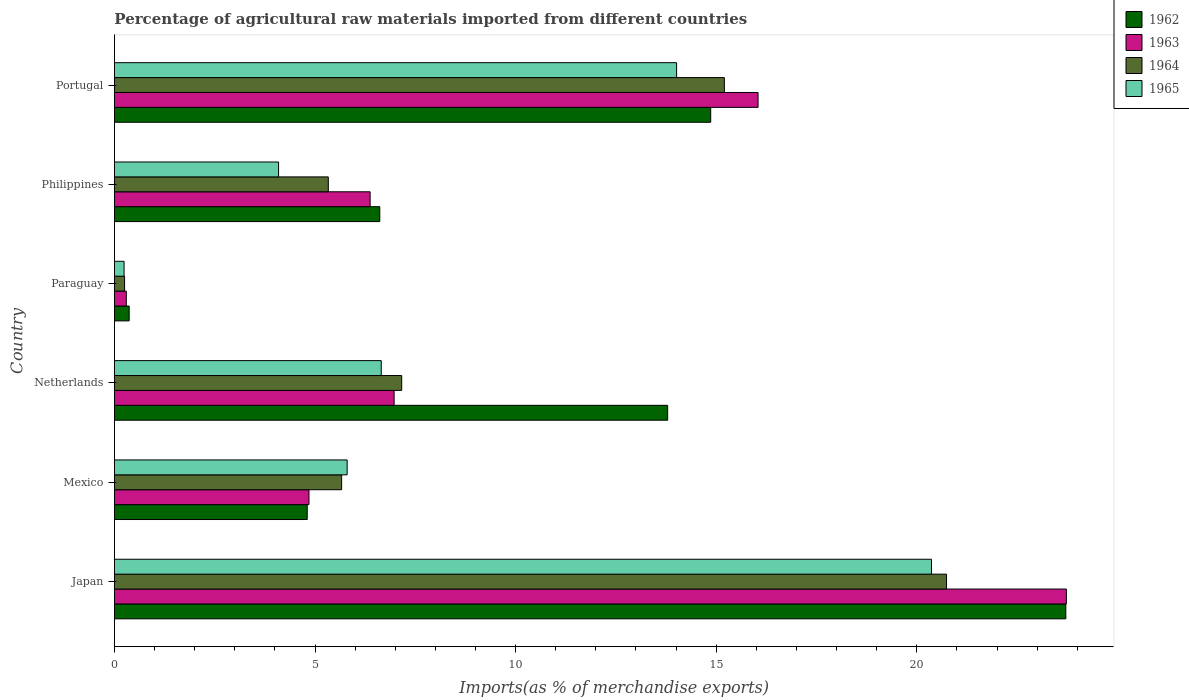How many different coloured bars are there?
Ensure brevity in your answer.  4. How many groups of bars are there?
Ensure brevity in your answer.  6. Are the number of bars on each tick of the Y-axis equal?
Make the answer very short. Yes. What is the label of the 6th group of bars from the top?
Give a very brief answer. Japan. What is the percentage of imports to different countries in 1962 in Portugal?
Ensure brevity in your answer.  14.86. Across all countries, what is the maximum percentage of imports to different countries in 1964?
Make the answer very short. 20.74. Across all countries, what is the minimum percentage of imports to different countries in 1965?
Ensure brevity in your answer.  0.24. In which country was the percentage of imports to different countries in 1964 maximum?
Offer a very short reply. Japan. In which country was the percentage of imports to different countries in 1965 minimum?
Give a very brief answer. Paraguay. What is the total percentage of imports to different countries in 1964 in the graph?
Keep it short and to the point. 54.35. What is the difference between the percentage of imports to different countries in 1965 in Mexico and that in Netherlands?
Ensure brevity in your answer.  -0.85. What is the difference between the percentage of imports to different countries in 1963 in Paraguay and the percentage of imports to different countries in 1964 in Netherlands?
Ensure brevity in your answer.  -6.86. What is the average percentage of imports to different countries in 1964 per country?
Your response must be concise. 9.06. What is the difference between the percentage of imports to different countries in 1963 and percentage of imports to different countries in 1964 in Paraguay?
Offer a very short reply. 0.04. What is the ratio of the percentage of imports to different countries in 1962 in Paraguay to that in Philippines?
Your answer should be compact. 0.06. Is the percentage of imports to different countries in 1963 in Japan less than that in Mexico?
Your response must be concise. No. Is the difference between the percentage of imports to different countries in 1963 in Netherlands and Philippines greater than the difference between the percentage of imports to different countries in 1964 in Netherlands and Philippines?
Provide a succinct answer. No. What is the difference between the highest and the second highest percentage of imports to different countries in 1962?
Offer a terse response. 8.85. What is the difference between the highest and the lowest percentage of imports to different countries in 1963?
Your answer should be very brief. 23.43. Is it the case that in every country, the sum of the percentage of imports to different countries in 1963 and percentage of imports to different countries in 1965 is greater than the sum of percentage of imports to different countries in 1962 and percentage of imports to different countries in 1964?
Your answer should be compact. No. What does the 2nd bar from the top in Portugal represents?
Your answer should be very brief. 1964. What does the 3rd bar from the bottom in Netherlands represents?
Offer a terse response. 1964. How many countries are there in the graph?
Ensure brevity in your answer.  6. What is the difference between two consecutive major ticks on the X-axis?
Make the answer very short. 5. Does the graph contain any zero values?
Keep it short and to the point. No. Where does the legend appear in the graph?
Offer a terse response. Top right. How many legend labels are there?
Provide a succinct answer. 4. What is the title of the graph?
Provide a succinct answer. Percentage of agricultural raw materials imported from different countries. Does "1976" appear as one of the legend labels in the graph?
Your answer should be very brief. No. What is the label or title of the X-axis?
Your answer should be very brief. Imports(as % of merchandise exports). What is the Imports(as % of merchandise exports) in 1962 in Japan?
Keep it short and to the point. 23.71. What is the Imports(as % of merchandise exports) of 1963 in Japan?
Ensure brevity in your answer.  23.73. What is the Imports(as % of merchandise exports) in 1964 in Japan?
Provide a succinct answer. 20.74. What is the Imports(as % of merchandise exports) of 1965 in Japan?
Offer a very short reply. 20.37. What is the Imports(as % of merchandise exports) in 1962 in Mexico?
Give a very brief answer. 4.81. What is the Imports(as % of merchandise exports) in 1963 in Mexico?
Make the answer very short. 4.85. What is the Imports(as % of merchandise exports) of 1964 in Mexico?
Provide a succinct answer. 5.66. What is the Imports(as % of merchandise exports) in 1965 in Mexico?
Ensure brevity in your answer.  5.8. What is the Imports(as % of merchandise exports) of 1962 in Netherlands?
Your response must be concise. 13.79. What is the Imports(as % of merchandise exports) of 1963 in Netherlands?
Make the answer very short. 6.97. What is the Imports(as % of merchandise exports) of 1964 in Netherlands?
Your response must be concise. 7.16. What is the Imports(as % of merchandise exports) of 1965 in Netherlands?
Give a very brief answer. 6.65. What is the Imports(as % of merchandise exports) of 1962 in Paraguay?
Make the answer very short. 0.37. What is the Imports(as % of merchandise exports) of 1963 in Paraguay?
Give a very brief answer. 0.3. What is the Imports(as % of merchandise exports) of 1964 in Paraguay?
Give a very brief answer. 0.25. What is the Imports(as % of merchandise exports) in 1965 in Paraguay?
Your answer should be very brief. 0.24. What is the Imports(as % of merchandise exports) of 1962 in Philippines?
Offer a very short reply. 6.61. What is the Imports(as % of merchandise exports) of 1963 in Philippines?
Your answer should be compact. 6.37. What is the Imports(as % of merchandise exports) in 1964 in Philippines?
Offer a very short reply. 5.33. What is the Imports(as % of merchandise exports) of 1965 in Philippines?
Offer a terse response. 4.09. What is the Imports(as % of merchandise exports) in 1962 in Portugal?
Offer a very short reply. 14.86. What is the Imports(as % of merchandise exports) of 1963 in Portugal?
Your answer should be very brief. 16.04. What is the Imports(as % of merchandise exports) of 1964 in Portugal?
Your response must be concise. 15.2. What is the Imports(as % of merchandise exports) of 1965 in Portugal?
Your response must be concise. 14.01. Across all countries, what is the maximum Imports(as % of merchandise exports) of 1962?
Offer a very short reply. 23.71. Across all countries, what is the maximum Imports(as % of merchandise exports) in 1963?
Offer a very short reply. 23.73. Across all countries, what is the maximum Imports(as % of merchandise exports) of 1964?
Keep it short and to the point. 20.74. Across all countries, what is the maximum Imports(as % of merchandise exports) of 1965?
Your answer should be compact. 20.37. Across all countries, what is the minimum Imports(as % of merchandise exports) of 1962?
Give a very brief answer. 0.37. Across all countries, what is the minimum Imports(as % of merchandise exports) in 1963?
Ensure brevity in your answer.  0.3. Across all countries, what is the minimum Imports(as % of merchandise exports) in 1964?
Offer a terse response. 0.25. Across all countries, what is the minimum Imports(as % of merchandise exports) in 1965?
Offer a very short reply. 0.24. What is the total Imports(as % of merchandise exports) in 1962 in the graph?
Offer a terse response. 64.16. What is the total Imports(as % of merchandise exports) in 1963 in the graph?
Give a very brief answer. 58.26. What is the total Imports(as % of merchandise exports) in 1964 in the graph?
Offer a very short reply. 54.35. What is the total Imports(as % of merchandise exports) in 1965 in the graph?
Give a very brief answer. 51.16. What is the difference between the Imports(as % of merchandise exports) in 1962 in Japan and that in Mexico?
Your answer should be very brief. 18.91. What is the difference between the Imports(as % of merchandise exports) in 1963 in Japan and that in Mexico?
Your answer should be very brief. 18.88. What is the difference between the Imports(as % of merchandise exports) of 1964 in Japan and that in Mexico?
Your answer should be compact. 15.08. What is the difference between the Imports(as % of merchandise exports) of 1965 in Japan and that in Mexico?
Make the answer very short. 14.56. What is the difference between the Imports(as % of merchandise exports) in 1962 in Japan and that in Netherlands?
Provide a succinct answer. 9.93. What is the difference between the Imports(as % of merchandise exports) in 1963 in Japan and that in Netherlands?
Keep it short and to the point. 16.76. What is the difference between the Imports(as % of merchandise exports) in 1964 in Japan and that in Netherlands?
Give a very brief answer. 13.58. What is the difference between the Imports(as % of merchandise exports) of 1965 in Japan and that in Netherlands?
Offer a very short reply. 13.72. What is the difference between the Imports(as % of merchandise exports) in 1962 in Japan and that in Paraguay?
Your answer should be compact. 23.35. What is the difference between the Imports(as % of merchandise exports) of 1963 in Japan and that in Paraguay?
Provide a succinct answer. 23.43. What is the difference between the Imports(as % of merchandise exports) in 1964 in Japan and that in Paraguay?
Provide a short and direct response. 20.49. What is the difference between the Imports(as % of merchandise exports) in 1965 in Japan and that in Paraguay?
Offer a terse response. 20.13. What is the difference between the Imports(as % of merchandise exports) in 1962 in Japan and that in Philippines?
Make the answer very short. 17.1. What is the difference between the Imports(as % of merchandise exports) in 1963 in Japan and that in Philippines?
Offer a very short reply. 17.36. What is the difference between the Imports(as % of merchandise exports) of 1964 in Japan and that in Philippines?
Give a very brief answer. 15.41. What is the difference between the Imports(as % of merchandise exports) in 1965 in Japan and that in Philippines?
Make the answer very short. 16.27. What is the difference between the Imports(as % of merchandise exports) of 1962 in Japan and that in Portugal?
Make the answer very short. 8.85. What is the difference between the Imports(as % of merchandise exports) of 1963 in Japan and that in Portugal?
Your response must be concise. 7.69. What is the difference between the Imports(as % of merchandise exports) in 1964 in Japan and that in Portugal?
Offer a terse response. 5.54. What is the difference between the Imports(as % of merchandise exports) in 1965 in Japan and that in Portugal?
Make the answer very short. 6.35. What is the difference between the Imports(as % of merchandise exports) in 1962 in Mexico and that in Netherlands?
Your answer should be very brief. -8.98. What is the difference between the Imports(as % of merchandise exports) of 1963 in Mexico and that in Netherlands?
Your answer should be compact. -2.12. What is the difference between the Imports(as % of merchandise exports) in 1964 in Mexico and that in Netherlands?
Your response must be concise. -1.5. What is the difference between the Imports(as % of merchandise exports) in 1965 in Mexico and that in Netherlands?
Your response must be concise. -0.85. What is the difference between the Imports(as % of merchandise exports) in 1962 in Mexico and that in Paraguay?
Offer a terse response. 4.44. What is the difference between the Imports(as % of merchandise exports) in 1963 in Mexico and that in Paraguay?
Keep it short and to the point. 4.55. What is the difference between the Imports(as % of merchandise exports) in 1964 in Mexico and that in Paraguay?
Offer a very short reply. 5.41. What is the difference between the Imports(as % of merchandise exports) in 1965 in Mexico and that in Paraguay?
Offer a terse response. 5.56. What is the difference between the Imports(as % of merchandise exports) in 1962 in Mexico and that in Philippines?
Provide a short and direct response. -1.81. What is the difference between the Imports(as % of merchandise exports) of 1963 in Mexico and that in Philippines?
Your answer should be compact. -1.52. What is the difference between the Imports(as % of merchandise exports) in 1964 in Mexico and that in Philippines?
Ensure brevity in your answer.  0.33. What is the difference between the Imports(as % of merchandise exports) of 1965 in Mexico and that in Philippines?
Offer a very short reply. 1.71. What is the difference between the Imports(as % of merchandise exports) in 1962 in Mexico and that in Portugal?
Provide a succinct answer. -10.06. What is the difference between the Imports(as % of merchandise exports) in 1963 in Mexico and that in Portugal?
Offer a very short reply. -11.19. What is the difference between the Imports(as % of merchandise exports) in 1964 in Mexico and that in Portugal?
Provide a short and direct response. -9.54. What is the difference between the Imports(as % of merchandise exports) in 1965 in Mexico and that in Portugal?
Make the answer very short. -8.21. What is the difference between the Imports(as % of merchandise exports) in 1962 in Netherlands and that in Paraguay?
Ensure brevity in your answer.  13.42. What is the difference between the Imports(as % of merchandise exports) in 1963 in Netherlands and that in Paraguay?
Make the answer very short. 6.68. What is the difference between the Imports(as % of merchandise exports) in 1964 in Netherlands and that in Paraguay?
Make the answer very short. 6.91. What is the difference between the Imports(as % of merchandise exports) of 1965 in Netherlands and that in Paraguay?
Provide a succinct answer. 6.41. What is the difference between the Imports(as % of merchandise exports) of 1962 in Netherlands and that in Philippines?
Offer a terse response. 7.18. What is the difference between the Imports(as % of merchandise exports) in 1963 in Netherlands and that in Philippines?
Your answer should be very brief. 0.6. What is the difference between the Imports(as % of merchandise exports) in 1964 in Netherlands and that in Philippines?
Your response must be concise. 1.83. What is the difference between the Imports(as % of merchandise exports) in 1965 in Netherlands and that in Philippines?
Offer a terse response. 2.56. What is the difference between the Imports(as % of merchandise exports) of 1962 in Netherlands and that in Portugal?
Your answer should be compact. -1.07. What is the difference between the Imports(as % of merchandise exports) of 1963 in Netherlands and that in Portugal?
Your response must be concise. -9.07. What is the difference between the Imports(as % of merchandise exports) of 1964 in Netherlands and that in Portugal?
Provide a short and direct response. -8.04. What is the difference between the Imports(as % of merchandise exports) in 1965 in Netherlands and that in Portugal?
Give a very brief answer. -7.36. What is the difference between the Imports(as % of merchandise exports) of 1962 in Paraguay and that in Philippines?
Keep it short and to the point. -6.25. What is the difference between the Imports(as % of merchandise exports) in 1963 in Paraguay and that in Philippines?
Your answer should be compact. -6.08. What is the difference between the Imports(as % of merchandise exports) of 1964 in Paraguay and that in Philippines?
Make the answer very short. -5.08. What is the difference between the Imports(as % of merchandise exports) in 1965 in Paraguay and that in Philippines?
Your answer should be compact. -3.85. What is the difference between the Imports(as % of merchandise exports) of 1962 in Paraguay and that in Portugal?
Give a very brief answer. -14.5. What is the difference between the Imports(as % of merchandise exports) of 1963 in Paraguay and that in Portugal?
Your response must be concise. -15.75. What is the difference between the Imports(as % of merchandise exports) in 1964 in Paraguay and that in Portugal?
Give a very brief answer. -14.95. What is the difference between the Imports(as % of merchandise exports) of 1965 in Paraguay and that in Portugal?
Ensure brevity in your answer.  -13.77. What is the difference between the Imports(as % of merchandise exports) of 1962 in Philippines and that in Portugal?
Keep it short and to the point. -8.25. What is the difference between the Imports(as % of merchandise exports) in 1963 in Philippines and that in Portugal?
Offer a terse response. -9.67. What is the difference between the Imports(as % of merchandise exports) in 1964 in Philippines and that in Portugal?
Provide a succinct answer. -9.87. What is the difference between the Imports(as % of merchandise exports) of 1965 in Philippines and that in Portugal?
Give a very brief answer. -9.92. What is the difference between the Imports(as % of merchandise exports) in 1962 in Japan and the Imports(as % of merchandise exports) in 1963 in Mexico?
Your answer should be compact. 18.87. What is the difference between the Imports(as % of merchandise exports) of 1962 in Japan and the Imports(as % of merchandise exports) of 1964 in Mexico?
Provide a short and direct response. 18.05. What is the difference between the Imports(as % of merchandise exports) in 1962 in Japan and the Imports(as % of merchandise exports) in 1965 in Mexico?
Your response must be concise. 17.91. What is the difference between the Imports(as % of merchandise exports) in 1963 in Japan and the Imports(as % of merchandise exports) in 1964 in Mexico?
Give a very brief answer. 18.07. What is the difference between the Imports(as % of merchandise exports) in 1963 in Japan and the Imports(as % of merchandise exports) in 1965 in Mexico?
Your answer should be compact. 17.93. What is the difference between the Imports(as % of merchandise exports) of 1964 in Japan and the Imports(as % of merchandise exports) of 1965 in Mexico?
Ensure brevity in your answer.  14.94. What is the difference between the Imports(as % of merchandise exports) of 1962 in Japan and the Imports(as % of merchandise exports) of 1963 in Netherlands?
Offer a very short reply. 16.74. What is the difference between the Imports(as % of merchandise exports) of 1962 in Japan and the Imports(as % of merchandise exports) of 1964 in Netherlands?
Ensure brevity in your answer.  16.55. What is the difference between the Imports(as % of merchandise exports) of 1962 in Japan and the Imports(as % of merchandise exports) of 1965 in Netherlands?
Your answer should be very brief. 17.06. What is the difference between the Imports(as % of merchandise exports) of 1963 in Japan and the Imports(as % of merchandise exports) of 1964 in Netherlands?
Make the answer very short. 16.57. What is the difference between the Imports(as % of merchandise exports) in 1963 in Japan and the Imports(as % of merchandise exports) in 1965 in Netherlands?
Make the answer very short. 17.08. What is the difference between the Imports(as % of merchandise exports) of 1964 in Japan and the Imports(as % of merchandise exports) of 1965 in Netherlands?
Provide a succinct answer. 14.09. What is the difference between the Imports(as % of merchandise exports) of 1962 in Japan and the Imports(as % of merchandise exports) of 1963 in Paraguay?
Provide a short and direct response. 23.42. What is the difference between the Imports(as % of merchandise exports) of 1962 in Japan and the Imports(as % of merchandise exports) of 1964 in Paraguay?
Your answer should be very brief. 23.46. What is the difference between the Imports(as % of merchandise exports) in 1962 in Japan and the Imports(as % of merchandise exports) in 1965 in Paraguay?
Your answer should be very brief. 23.47. What is the difference between the Imports(as % of merchandise exports) in 1963 in Japan and the Imports(as % of merchandise exports) in 1964 in Paraguay?
Your answer should be compact. 23.48. What is the difference between the Imports(as % of merchandise exports) in 1963 in Japan and the Imports(as % of merchandise exports) in 1965 in Paraguay?
Provide a short and direct response. 23.49. What is the difference between the Imports(as % of merchandise exports) of 1964 in Japan and the Imports(as % of merchandise exports) of 1965 in Paraguay?
Provide a short and direct response. 20.5. What is the difference between the Imports(as % of merchandise exports) of 1962 in Japan and the Imports(as % of merchandise exports) of 1963 in Philippines?
Provide a succinct answer. 17.34. What is the difference between the Imports(as % of merchandise exports) in 1962 in Japan and the Imports(as % of merchandise exports) in 1964 in Philippines?
Make the answer very short. 18.38. What is the difference between the Imports(as % of merchandise exports) in 1962 in Japan and the Imports(as % of merchandise exports) in 1965 in Philippines?
Provide a succinct answer. 19.62. What is the difference between the Imports(as % of merchandise exports) in 1963 in Japan and the Imports(as % of merchandise exports) in 1964 in Philippines?
Your answer should be compact. 18.4. What is the difference between the Imports(as % of merchandise exports) of 1963 in Japan and the Imports(as % of merchandise exports) of 1965 in Philippines?
Your response must be concise. 19.64. What is the difference between the Imports(as % of merchandise exports) of 1964 in Japan and the Imports(as % of merchandise exports) of 1965 in Philippines?
Ensure brevity in your answer.  16.65. What is the difference between the Imports(as % of merchandise exports) of 1962 in Japan and the Imports(as % of merchandise exports) of 1963 in Portugal?
Your answer should be compact. 7.67. What is the difference between the Imports(as % of merchandise exports) of 1962 in Japan and the Imports(as % of merchandise exports) of 1964 in Portugal?
Offer a very short reply. 8.51. What is the difference between the Imports(as % of merchandise exports) of 1962 in Japan and the Imports(as % of merchandise exports) of 1965 in Portugal?
Offer a very short reply. 9.7. What is the difference between the Imports(as % of merchandise exports) in 1963 in Japan and the Imports(as % of merchandise exports) in 1964 in Portugal?
Give a very brief answer. 8.53. What is the difference between the Imports(as % of merchandise exports) in 1963 in Japan and the Imports(as % of merchandise exports) in 1965 in Portugal?
Offer a terse response. 9.72. What is the difference between the Imports(as % of merchandise exports) of 1964 in Japan and the Imports(as % of merchandise exports) of 1965 in Portugal?
Make the answer very short. 6.73. What is the difference between the Imports(as % of merchandise exports) of 1962 in Mexico and the Imports(as % of merchandise exports) of 1963 in Netherlands?
Your response must be concise. -2.17. What is the difference between the Imports(as % of merchandise exports) of 1962 in Mexico and the Imports(as % of merchandise exports) of 1964 in Netherlands?
Give a very brief answer. -2.36. What is the difference between the Imports(as % of merchandise exports) of 1962 in Mexico and the Imports(as % of merchandise exports) of 1965 in Netherlands?
Make the answer very short. -1.85. What is the difference between the Imports(as % of merchandise exports) of 1963 in Mexico and the Imports(as % of merchandise exports) of 1964 in Netherlands?
Offer a very short reply. -2.31. What is the difference between the Imports(as % of merchandise exports) in 1963 in Mexico and the Imports(as % of merchandise exports) in 1965 in Netherlands?
Your answer should be very brief. -1.8. What is the difference between the Imports(as % of merchandise exports) of 1964 in Mexico and the Imports(as % of merchandise exports) of 1965 in Netherlands?
Give a very brief answer. -0.99. What is the difference between the Imports(as % of merchandise exports) in 1962 in Mexico and the Imports(as % of merchandise exports) in 1963 in Paraguay?
Give a very brief answer. 4.51. What is the difference between the Imports(as % of merchandise exports) in 1962 in Mexico and the Imports(as % of merchandise exports) in 1964 in Paraguay?
Give a very brief answer. 4.55. What is the difference between the Imports(as % of merchandise exports) in 1962 in Mexico and the Imports(as % of merchandise exports) in 1965 in Paraguay?
Your answer should be compact. 4.57. What is the difference between the Imports(as % of merchandise exports) in 1963 in Mexico and the Imports(as % of merchandise exports) in 1964 in Paraguay?
Offer a terse response. 4.6. What is the difference between the Imports(as % of merchandise exports) of 1963 in Mexico and the Imports(as % of merchandise exports) of 1965 in Paraguay?
Your answer should be very brief. 4.61. What is the difference between the Imports(as % of merchandise exports) of 1964 in Mexico and the Imports(as % of merchandise exports) of 1965 in Paraguay?
Provide a succinct answer. 5.42. What is the difference between the Imports(as % of merchandise exports) of 1962 in Mexico and the Imports(as % of merchandise exports) of 1963 in Philippines?
Your response must be concise. -1.57. What is the difference between the Imports(as % of merchandise exports) of 1962 in Mexico and the Imports(as % of merchandise exports) of 1964 in Philippines?
Your answer should be compact. -0.53. What is the difference between the Imports(as % of merchandise exports) in 1962 in Mexico and the Imports(as % of merchandise exports) in 1965 in Philippines?
Your answer should be compact. 0.71. What is the difference between the Imports(as % of merchandise exports) of 1963 in Mexico and the Imports(as % of merchandise exports) of 1964 in Philippines?
Make the answer very short. -0.48. What is the difference between the Imports(as % of merchandise exports) of 1963 in Mexico and the Imports(as % of merchandise exports) of 1965 in Philippines?
Your answer should be very brief. 0.76. What is the difference between the Imports(as % of merchandise exports) of 1964 in Mexico and the Imports(as % of merchandise exports) of 1965 in Philippines?
Ensure brevity in your answer.  1.57. What is the difference between the Imports(as % of merchandise exports) of 1962 in Mexico and the Imports(as % of merchandise exports) of 1963 in Portugal?
Your answer should be very brief. -11.24. What is the difference between the Imports(as % of merchandise exports) in 1962 in Mexico and the Imports(as % of merchandise exports) in 1964 in Portugal?
Offer a very short reply. -10.4. What is the difference between the Imports(as % of merchandise exports) in 1962 in Mexico and the Imports(as % of merchandise exports) in 1965 in Portugal?
Offer a very short reply. -9.21. What is the difference between the Imports(as % of merchandise exports) in 1963 in Mexico and the Imports(as % of merchandise exports) in 1964 in Portugal?
Give a very brief answer. -10.35. What is the difference between the Imports(as % of merchandise exports) in 1963 in Mexico and the Imports(as % of merchandise exports) in 1965 in Portugal?
Offer a terse response. -9.16. What is the difference between the Imports(as % of merchandise exports) in 1964 in Mexico and the Imports(as % of merchandise exports) in 1965 in Portugal?
Offer a terse response. -8.35. What is the difference between the Imports(as % of merchandise exports) in 1962 in Netherlands and the Imports(as % of merchandise exports) in 1963 in Paraguay?
Your answer should be very brief. 13.49. What is the difference between the Imports(as % of merchandise exports) of 1962 in Netherlands and the Imports(as % of merchandise exports) of 1964 in Paraguay?
Offer a terse response. 13.54. What is the difference between the Imports(as % of merchandise exports) of 1962 in Netherlands and the Imports(as % of merchandise exports) of 1965 in Paraguay?
Ensure brevity in your answer.  13.55. What is the difference between the Imports(as % of merchandise exports) of 1963 in Netherlands and the Imports(as % of merchandise exports) of 1964 in Paraguay?
Offer a very short reply. 6.72. What is the difference between the Imports(as % of merchandise exports) of 1963 in Netherlands and the Imports(as % of merchandise exports) of 1965 in Paraguay?
Your answer should be very brief. 6.73. What is the difference between the Imports(as % of merchandise exports) of 1964 in Netherlands and the Imports(as % of merchandise exports) of 1965 in Paraguay?
Ensure brevity in your answer.  6.92. What is the difference between the Imports(as % of merchandise exports) of 1962 in Netherlands and the Imports(as % of merchandise exports) of 1963 in Philippines?
Offer a terse response. 7.42. What is the difference between the Imports(as % of merchandise exports) in 1962 in Netherlands and the Imports(as % of merchandise exports) in 1964 in Philippines?
Give a very brief answer. 8.46. What is the difference between the Imports(as % of merchandise exports) of 1962 in Netherlands and the Imports(as % of merchandise exports) of 1965 in Philippines?
Keep it short and to the point. 9.7. What is the difference between the Imports(as % of merchandise exports) in 1963 in Netherlands and the Imports(as % of merchandise exports) in 1964 in Philippines?
Your response must be concise. 1.64. What is the difference between the Imports(as % of merchandise exports) in 1963 in Netherlands and the Imports(as % of merchandise exports) in 1965 in Philippines?
Offer a terse response. 2.88. What is the difference between the Imports(as % of merchandise exports) in 1964 in Netherlands and the Imports(as % of merchandise exports) in 1965 in Philippines?
Your response must be concise. 3.07. What is the difference between the Imports(as % of merchandise exports) of 1962 in Netherlands and the Imports(as % of merchandise exports) of 1963 in Portugal?
Give a very brief answer. -2.25. What is the difference between the Imports(as % of merchandise exports) of 1962 in Netherlands and the Imports(as % of merchandise exports) of 1964 in Portugal?
Your response must be concise. -1.41. What is the difference between the Imports(as % of merchandise exports) of 1962 in Netherlands and the Imports(as % of merchandise exports) of 1965 in Portugal?
Offer a terse response. -0.22. What is the difference between the Imports(as % of merchandise exports) of 1963 in Netherlands and the Imports(as % of merchandise exports) of 1964 in Portugal?
Offer a terse response. -8.23. What is the difference between the Imports(as % of merchandise exports) in 1963 in Netherlands and the Imports(as % of merchandise exports) in 1965 in Portugal?
Provide a succinct answer. -7.04. What is the difference between the Imports(as % of merchandise exports) of 1964 in Netherlands and the Imports(as % of merchandise exports) of 1965 in Portugal?
Make the answer very short. -6.85. What is the difference between the Imports(as % of merchandise exports) of 1962 in Paraguay and the Imports(as % of merchandise exports) of 1963 in Philippines?
Ensure brevity in your answer.  -6.01. What is the difference between the Imports(as % of merchandise exports) in 1962 in Paraguay and the Imports(as % of merchandise exports) in 1964 in Philippines?
Provide a short and direct response. -4.96. What is the difference between the Imports(as % of merchandise exports) of 1962 in Paraguay and the Imports(as % of merchandise exports) of 1965 in Philippines?
Provide a succinct answer. -3.72. What is the difference between the Imports(as % of merchandise exports) in 1963 in Paraguay and the Imports(as % of merchandise exports) in 1964 in Philippines?
Offer a terse response. -5.04. What is the difference between the Imports(as % of merchandise exports) in 1963 in Paraguay and the Imports(as % of merchandise exports) in 1965 in Philippines?
Offer a terse response. -3.8. What is the difference between the Imports(as % of merchandise exports) of 1964 in Paraguay and the Imports(as % of merchandise exports) of 1965 in Philippines?
Your answer should be very brief. -3.84. What is the difference between the Imports(as % of merchandise exports) of 1962 in Paraguay and the Imports(as % of merchandise exports) of 1963 in Portugal?
Provide a succinct answer. -15.68. What is the difference between the Imports(as % of merchandise exports) in 1962 in Paraguay and the Imports(as % of merchandise exports) in 1964 in Portugal?
Your answer should be very brief. -14.84. What is the difference between the Imports(as % of merchandise exports) of 1962 in Paraguay and the Imports(as % of merchandise exports) of 1965 in Portugal?
Ensure brevity in your answer.  -13.65. What is the difference between the Imports(as % of merchandise exports) in 1963 in Paraguay and the Imports(as % of merchandise exports) in 1964 in Portugal?
Provide a succinct answer. -14.91. What is the difference between the Imports(as % of merchandise exports) of 1963 in Paraguay and the Imports(as % of merchandise exports) of 1965 in Portugal?
Give a very brief answer. -13.72. What is the difference between the Imports(as % of merchandise exports) in 1964 in Paraguay and the Imports(as % of merchandise exports) in 1965 in Portugal?
Ensure brevity in your answer.  -13.76. What is the difference between the Imports(as % of merchandise exports) in 1962 in Philippines and the Imports(as % of merchandise exports) in 1963 in Portugal?
Offer a very short reply. -9.43. What is the difference between the Imports(as % of merchandise exports) in 1962 in Philippines and the Imports(as % of merchandise exports) in 1964 in Portugal?
Provide a succinct answer. -8.59. What is the difference between the Imports(as % of merchandise exports) of 1962 in Philippines and the Imports(as % of merchandise exports) of 1965 in Portugal?
Provide a short and direct response. -7.4. What is the difference between the Imports(as % of merchandise exports) in 1963 in Philippines and the Imports(as % of merchandise exports) in 1964 in Portugal?
Your response must be concise. -8.83. What is the difference between the Imports(as % of merchandise exports) in 1963 in Philippines and the Imports(as % of merchandise exports) in 1965 in Portugal?
Offer a very short reply. -7.64. What is the difference between the Imports(as % of merchandise exports) in 1964 in Philippines and the Imports(as % of merchandise exports) in 1965 in Portugal?
Keep it short and to the point. -8.68. What is the average Imports(as % of merchandise exports) of 1962 per country?
Your answer should be very brief. 10.69. What is the average Imports(as % of merchandise exports) of 1963 per country?
Your response must be concise. 9.71. What is the average Imports(as % of merchandise exports) of 1964 per country?
Your answer should be compact. 9.06. What is the average Imports(as % of merchandise exports) of 1965 per country?
Your answer should be compact. 8.53. What is the difference between the Imports(as % of merchandise exports) of 1962 and Imports(as % of merchandise exports) of 1963 in Japan?
Ensure brevity in your answer.  -0.01. What is the difference between the Imports(as % of merchandise exports) of 1962 and Imports(as % of merchandise exports) of 1964 in Japan?
Make the answer very short. 2.97. What is the difference between the Imports(as % of merchandise exports) of 1962 and Imports(as % of merchandise exports) of 1965 in Japan?
Keep it short and to the point. 3.35. What is the difference between the Imports(as % of merchandise exports) in 1963 and Imports(as % of merchandise exports) in 1964 in Japan?
Your response must be concise. 2.99. What is the difference between the Imports(as % of merchandise exports) in 1963 and Imports(as % of merchandise exports) in 1965 in Japan?
Offer a terse response. 3.36. What is the difference between the Imports(as % of merchandise exports) of 1964 and Imports(as % of merchandise exports) of 1965 in Japan?
Ensure brevity in your answer.  0.38. What is the difference between the Imports(as % of merchandise exports) in 1962 and Imports(as % of merchandise exports) in 1963 in Mexico?
Keep it short and to the point. -0.04. What is the difference between the Imports(as % of merchandise exports) in 1962 and Imports(as % of merchandise exports) in 1964 in Mexico?
Your answer should be compact. -0.86. What is the difference between the Imports(as % of merchandise exports) of 1962 and Imports(as % of merchandise exports) of 1965 in Mexico?
Make the answer very short. -1. What is the difference between the Imports(as % of merchandise exports) in 1963 and Imports(as % of merchandise exports) in 1964 in Mexico?
Make the answer very short. -0.81. What is the difference between the Imports(as % of merchandise exports) in 1963 and Imports(as % of merchandise exports) in 1965 in Mexico?
Give a very brief answer. -0.95. What is the difference between the Imports(as % of merchandise exports) in 1964 and Imports(as % of merchandise exports) in 1965 in Mexico?
Offer a terse response. -0.14. What is the difference between the Imports(as % of merchandise exports) of 1962 and Imports(as % of merchandise exports) of 1963 in Netherlands?
Your response must be concise. 6.82. What is the difference between the Imports(as % of merchandise exports) of 1962 and Imports(as % of merchandise exports) of 1964 in Netherlands?
Keep it short and to the point. 6.63. What is the difference between the Imports(as % of merchandise exports) in 1962 and Imports(as % of merchandise exports) in 1965 in Netherlands?
Your answer should be very brief. 7.14. What is the difference between the Imports(as % of merchandise exports) of 1963 and Imports(as % of merchandise exports) of 1964 in Netherlands?
Make the answer very short. -0.19. What is the difference between the Imports(as % of merchandise exports) of 1963 and Imports(as % of merchandise exports) of 1965 in Netherlands?
Give a very brief answer. 0.32. What is the difference between the Imports(as % of merchandise exports) in 1964 and Imports(as % of merchandise exports) in 1965 in Netherlands?
Give a very brief answer. 0.51. What is the difference between the Imports(as % of merchandise exports) in 1962 and Imports(as % of merchandise exports) in 1963 in Paraguay?
Ensure brevity in your answer.  0.07. What is the difference between the Imports(as % of merchandise exports) in 1962 and Imports(as % of merchandise exports) in 1964 in Paraguay?
Make the answer very short. 0.11. What is the difference between the Imports(as % of merchandise exports) in 1962 and Imports(as % of merchandise exports) in 1965 in Paraguay?
Your response must be concise. 0.13. What is the difference between the Imports(as % of merchandise exports) in 1963 and Imports(as % of merchandise exports) in 1964 in Paraguay?
Ensure brevity in your answer.  0.04. What is the difference between the Imports(as % of merchandise exports) in 1963 and Imports(as % of merchandise exports) in 1965 in Paraguay?
Offer a terse response. 0.06. What is the difference between the Imports(as % of merchandise exports) of 1964 and Imports(as % of merchandise exports) of 1965 in Paraguay?
Your answer should be very brief. 0.01. What is the difference between the Imports(as % of merchandise exports) of 1962 and Imports(as % of merchandise exports) of 1963 in Philippines?
Ensure brevity in your answer.  0.24. What is the difference between the Imports(as % of merchandise exports) of 1962 and Imports(as % of merchandise exports) of 1964 in Philippines?
Make the answer very short. 1.28. What is the difference between the Imports(as % of merchandise exports) of 1962 and Imports(as % of merchandise exports) of 1965 in Philippines?
Offer a terse response. 2.52. What is the difference between the Imports(as % of merchandise exports) in 1963 and Imports(as % of merchandise exports) in 1964 in Philippines?
Provide a succinct answer. 1.04. What is the difference between the Imports(as % of merchandise exports) in 1963 and Imports(as % of merchandise exports) in 1965 in Philippines?
Provide a succinct answer. 2.28. What is the difference between the Imports(as % of merchandise exports) in 1964 and Imports(as % of merchandise exports) in 1965 in Philippines?
Give a very brief answer. 1.24. What is the difference between the Imports(as % of merchandise exports) in 1962 and Imports(as % of merchandise exports) in 1963 in Portugal?
Give a very brief answer. -1.18. What is the difference between the Imports(as % of merchandise exports) in 1962 and Imports(as % of merchandise exports) in 1964 in Portugal?
Your answer should be very brief. -0.34. What is the difference between the Imports(as % of merchandise exports) of 1962 and Imports(as % of merchandise exports) of 1965 in Portugal?
Offer a terse response. 0.85. What is the difference between the Imports(as % of merchandise exports) in 1963 and Imports(as % of merchandise exports) in 1964 in Portugal?
Offer a very short reply. 0.84. What is the difference between the Imports(as % of merchandise exports) of 1963 and Imports(as % of merchandise exports) of 1965 in Portugal?
Provide a succinct answer. 2.03. What is the difference between the Imports(as % of merchandise exports) of 1964 and Imports(as % of merchandise exports) of 1965 in Portugal?
Your answer should be very brief. 1.19. What is the ratio of the Imports(as % of merchandise exports) of 1962 in Japan to that in Mexico?
Provide a short and direct response. 4.93. What is the ratio of the Imports(as % of merchandise exports) of 1963 in Japan to that in Mexico?
Your response must be concise. 4.89. What is the ratio of the Imports(as % of merchandise exports) of 1964 in Japan to that in Mexico?
Provide a short and direct response. 3.66. What is the ratio of the Imports(as % of merchandise exports) of 1965 in Japan to that in Mexico?
Keep it short and to the point. 3.51. What is the ratio of the Imports(as % of merchandise exports) of 1962 in Japan to that in Netherlands?
Keep it short and to the point. 1.72. What is the ratio of the Imports(as % of merchandise exports) in 1963 in Japan to that in Netherlands?
Offer a terse response. 3.4. What is the ratio of the Imports(as % of merchandise exports) of 1964 in Japan to that in Netherlands?
Make the answer very short. 2.9. What is the ratio of the Imports(as % of merchandise exports) in 1965 in Japan to that in Netherlands?
Ensure brevity in your answer.  3.06. What is the ratio of the Imports(as % of merchandise exports) in 1962 in Japan to that in Paraguay?
Your answer should be very brief. 64.56. What is the ratio of the Imports(as % of merchandise exports) of 1963 in Japan to that in Paraguay?
Provide a short and direct response. 80.13. What is the ratio of the Imports(as % of merchandise exports) of 1964 in Japan to that in Paraguay?
Provide a succinct answer. 82.04. What is the ratio of the Imports(as % of merchandise exports) of 1965 in Japan to that in Paraguay?
Your answer should be compact. 84.69. What is the ratio of the Imports(as % of merchandise exports) of 1962 in Japan to that in Philippines?
Your answer should be compact. 3.59. What is the ratio of the Imports(as % of merchandise exports) of 1963 in Japan to that in Philippines?
Offer a very short reply. 3.72. What is the ratio of the Imports(as % of merchandise exports) of 1964 in Japan to that in Philippines?
Offer a very short reply. 3.89. What is the ratio of the Imports(as % of merchandise exports) of 1965 in Japan to that in Philippines?
Your response must be concise. 4.98. What is the ratio of the Imports(as % of merchandise exports) of 1962 in Japan to that in Portugal?
Offer a terse response. 1.6. What is the ratio of the Imports(as % of merchandise exports) in 1963 in Japan to that in Portugal?
Ensure brevity in your answer.  1.48. What is the ratio of the Imports(as % of merchandise exports) of 1964 in Japan to that in Portugal?
Offer a very short reply. 1.36. What is the ratio of the Imports(as % of merchandise exports) in 1965 in Japan to that in Portugal?
Keep it short and to the point. 1.45. What is the ratio of the Imports(as % of merchandise exports) of 1962 in Mexico to that in Netherlands?
Give a very brief answer. 0.35. What is the ratio of the Imports(as % of merchandise exports) of 1963 in Mexico to that in Netherlands?
Your answer should be compact. 0.7. What is the ratio of the Imports(as % of merchandise exports) in 1964 in Mexico to that in Netherlands?
Your response must be concise. 0.79. What is the ratio of the Imports(as % of merchandise exports) in 1965 in Mexico to that in Netherlands?
Make the answer very short. 0.87. What is the ratio of the Imports(as % of merchandise exports) in 1962 in Mexico to that in Paraguay?
Give a very brief answer. 13.08. What is the ratio of the Imports(as % of merchandise exports) of 1963 in Mexico to that in Paraguay?
Give a very brief answer. 16.38. What is the ratio of the Imports(as % of merchandise exports) of 1964 in Mexico to that in Paraguay?
Ensure brevity in your answer.  22.4. What is the ratio of the Imports(as % of merchandise exports) of 1965 in Mexico to that in Paraguay?
Provide a succinct answer. 24.12. What is the ratio of the Imports(as % of merchandise exports) of 1962 in Mexico to that in Philippines?
Provide a succinct answer. 0.73. What is the ratio of the Imports(as % of merchandise exports) in 1963 in Mexico to that in Philippines?
Provide a succinct answer. 0.76. What is the ratio of the Imports(as % of merchandise exports) of 1964 in Mexico to that in Philippines?
Offer a terse response. 1.06. What is the ratio of the Imports(as % of merchandise exports) in 1965 in Mexico to that in Philippines?
Offer a terse response. 1.42. What is the ratio of the Imports(as % of merchandise exports) in 1962 in Mexico to that in Portugal?
Ensure brevity in your answer.  0.32. What is the ratio of the Imports(as % of merchandise exports) of 1963 in Mexico to that in Portugal?
Ensure brevity in your answer.  0.3. What is the ratio of the Imports(as % of merchandise exports) of 1964 in Mexico to that in Portugal?
Provide a short and direct response. 0.37. What is the ratio of the Imports(as % of merchandise exports) of 1965 in Mexico to that in Portugal?
Provide a short and direct response. 0.41. What is the ratio of the Imports(as % of merchandise exports) in 1962 in Netherlands to that in Paraguay?
Offer a terse response. 37.54. What is the ratio of the Imports(as % of merchandise exports) of 1963 in Netherlands to that in Paraguay?
Make the answer very short. 23.54. What is the ratio of the Imports(as % of merchandise exports) in 1964 in Netherlands to that in Paraguay?
Your answer should be compact. 28.32. What is the ratio of the Imports(as % of merchandise exports) in 1965 in Netherlands to that in Paraguay?
Make the answer very short. 27.66. What is the ratio of the Imports(as % of merchandise exports) in 1962 in Netherlands to that in Philippines?
Provide a succinct answer. 2.08. What is the ratio of the Imports(as % of merchandise exports) of 1963 in Netherlands to that in Philippines?
Ensure brevity in your answer.  1.09. What is the ratio of the Imports(as % of merchandise exports) of 1964 in Netherlands to that in Philippines?
Your answer should be very brief. 1.34. What is the ratio of the Imports(as % of merchandise exports) of 1965 in Netherlands to that in Philippines?
Provide a succinct answer. 1.63. What is the ratio of the Imports(as % of merchandise exports) of 1962 in Netherlands to that in Portugal?
Your answer should be compact. 0.93. What is the ratio of the Imports(as % of merchandise exports) in 1963 in Netherlands to that in Portugal?
Offer a terse response. 0.43. What is the ratio of the Imports(as % of merchandise exports) in 1964 in Netherlands to that in Portugal?
Provide a short and direct response. 0.47. What is the ratio of the Imports(as % of merchandise exports) in 1965 in Netherlands to that in Portugal?
Your answer should be very brief. 0.47. What is the ratio of the Imports(as % of merchandise exports) in 1962 in Paraguay to that in Philippines?
Make the answer very short. 0.06. What is the ratio of the Imports(as % of merchandise exports) of 1963 in Paraguay to that in Philippines?
Your response must be concise. 0.05. What is the ratio of the Imports(as % of merchandise exports) in 1964 in Paraguay to that in Philippines?
Offer a terse response. 0.05. What is the ratio of the Imports(as % of merchandise exports) in 1965 in Paraguay to that in Philippines?
Offer a terse response. 0.06. What is the ratio of the Imports(as % of merchandise exports) in 1962 in Paraguay to that in Portugal?
Keep it short and to the point. 0.02. What is the ratio of the Imports(as % of merchandise exports) in 1963 in Paraguay to that in Portugal?
Your answer should be compact. 0.02. What is the ratio of the Imports(as % of merchandise exports) of 1964 in Paraguay to that in Portugal?
Keep it short and to the point. 0.02. What is the ratio of the Imports(as % of merchandise exports) in 1965 in Paraguay to that in Portugal?
Provide a short and direct response. 0.02. What is the ratio of the Imports(as % of merchandise exports) in 1962 in Philippines to that in Portugal?
Provide a short and direct response. 0.45. What is the ratio of the Imports(as % of merchandise exports) of 1963 in Philippines to that in Portugal?
Make the answer very short. 0.4. What is the ratio of the Imports(as % of merchandise exports) in 1964 in Philippines to that in Portugal?
Ensure brevity in your answer.  0.35. What is the ratio of the Imports(as % of merchandise exports) in 1965 in Philippines to that in Portugal?
Ensure brevity in your answer.  0.29. What is the difference between the highest and the second highest Imports(as % of merchandise exports) in 1962?
Offer a very short reply. 8.85. What is the difference between the highest and the second highest Imports(as % of merchandise exports) of 1963?
Offer a very short reply. 7.69. What is the difference between the highest and the second highest Imports(as % of merchandise exports) in 1964?
Your answer should be compact. 5.54. What is the difference between the highest and the second highest Imports(as % of merchandise exports) of 1965?
Ensure brevity in your answer.  6.35. What is the difference between the highest and the lowest Imports(as % of merchandise exports) in 1962?
Provide a succinct answer. 23.35. What is the difference between the highest and the lowest Imports(as % of merchandise exports) of 1963?
Keep it short and to the point. 23.43. What is the difference between the highest and the lowest Imports(as % of merchandise exports) in 1964?
Keep it short and to the point. 20.49. What is the difference between the highest and the lowest Imports(as % of merchandise exports) of 1965?
Your answer should be very brief. 20.13. 